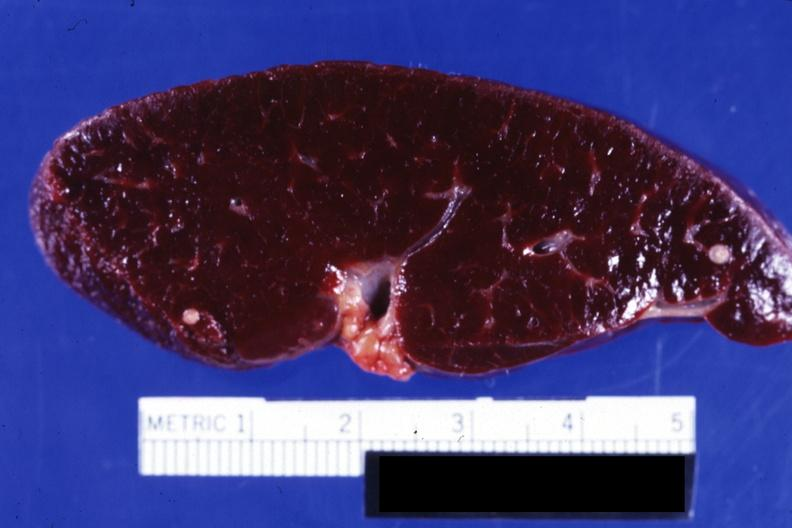does this image show close-up of cut surface showing two typical old granulomas?
Answer the question using a single word or phrase. Yes 